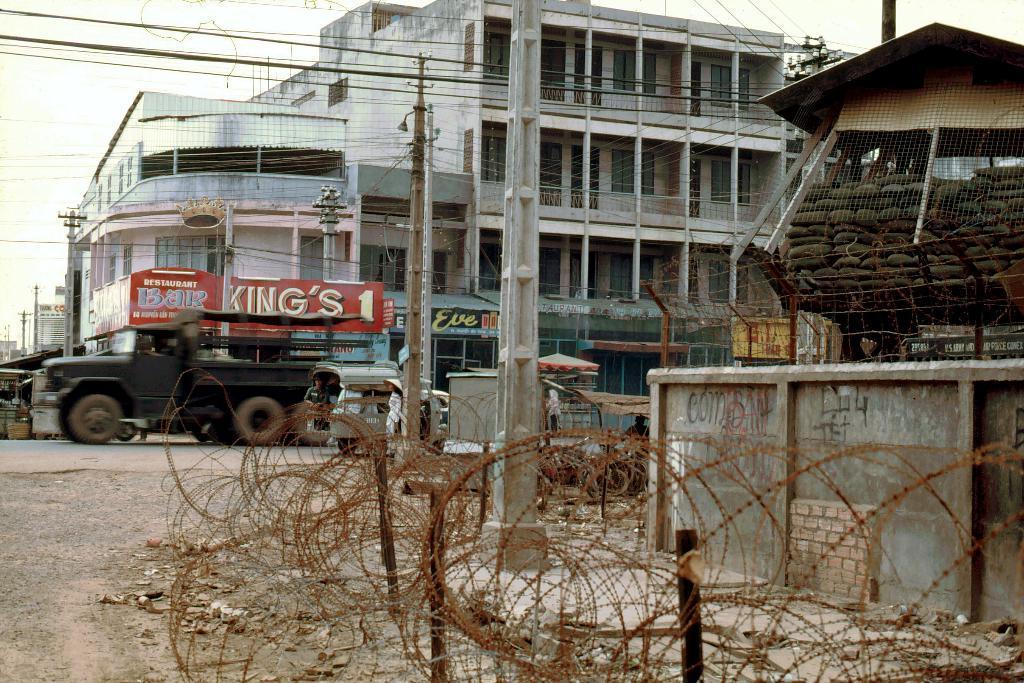Please provide a concise description of this image. In this picture we can see a white color building. In the front there is a truck which is moving on the road and some poles and cables. On the front bottom side there is a round fencing grill. 